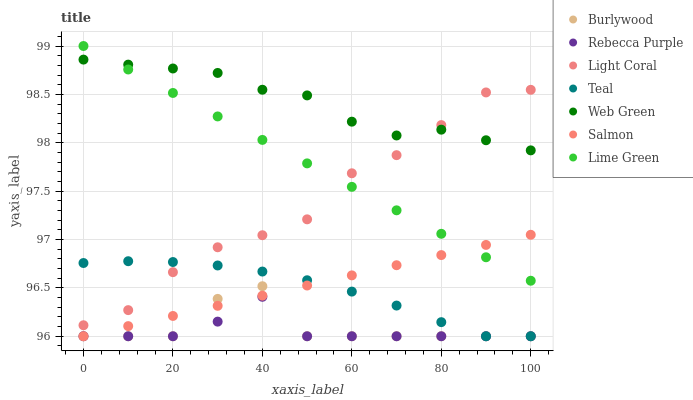Does Rebecca Purple have the minimum area under the curve?
Answer yes or no. Yes. Does Web Green have the maximum area under the curve?
Answer yes or no. Yes. Does Salmon have the minimum area under the curve?
Answer yes or no. No. Does Salmon have the maximum area under the curve?
Answer yes or no. No. Is Salmon the smoothest?
Answer yes or no. Yes. Is Burlywood the roughest?
Answer yes or no. Yes. Is Web Green the smoothest?
Answer yes or no. No. Is Web Green the roughest?
Answer yes or no. No. Does Burlywood have the lowest value?
Answer yes or no. Yes. Does Web Green have the lowest value?
Answer yes or no. No. Does Lime Green have the highest value?
Answer yes or no. Yes. Does Salmon have the highest value?
Answer yes or no. No. Is Teal less than Web Green?
Answer yes or no. Yes. Is Lime Green greater than Teal?
Answer yes or no. Yes. Does Teal intersect Burlywood?
Answer yes or no. Yes. Is Teal less than Burlywood?
Answer yes or no. No. Is Teal greater than Burlywood?
Answer yes or no. No. Does Teal intersect Web Green?
Answer yes or no. No. 